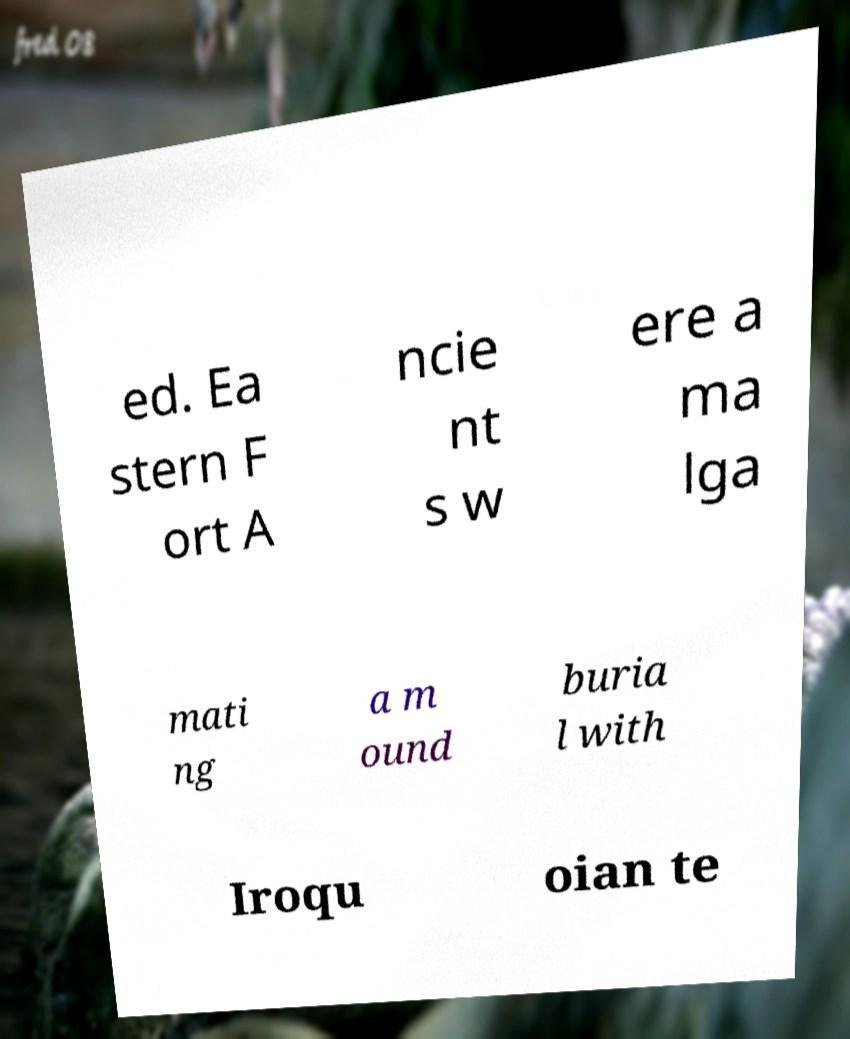Could you assist in decoding the text presented in this image and type it out clearly? ed. Ea stern F ort A ncie nt s w ere a ma lga mati ng a m ound buria l with Iroqu oian te 